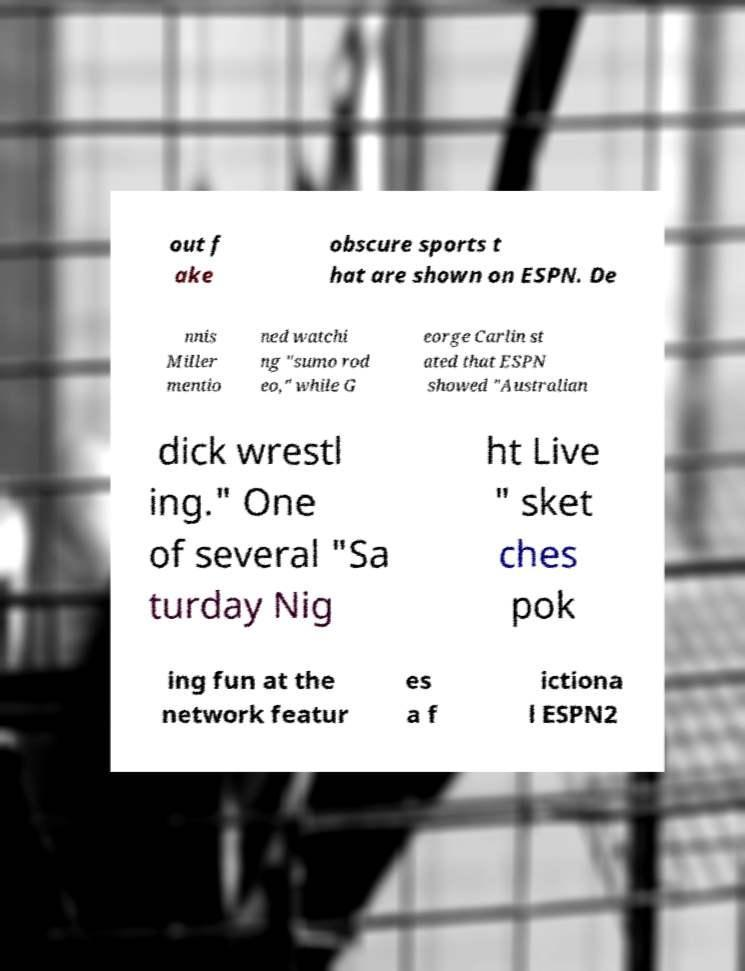I need the written content from this picture converted into text. Can you do that? out f ake obscure sports t hat are shown on ESPN. De nnis Miller mentio ned watchi ng "sumo rod eo," while G eorge Carlin st ated that ESPN showed "Australian dick wrestl ing." One of several "Sa turday Nig ht Live " sket ches pok ing fun at the network featur es a f ictiona l ESPN2 